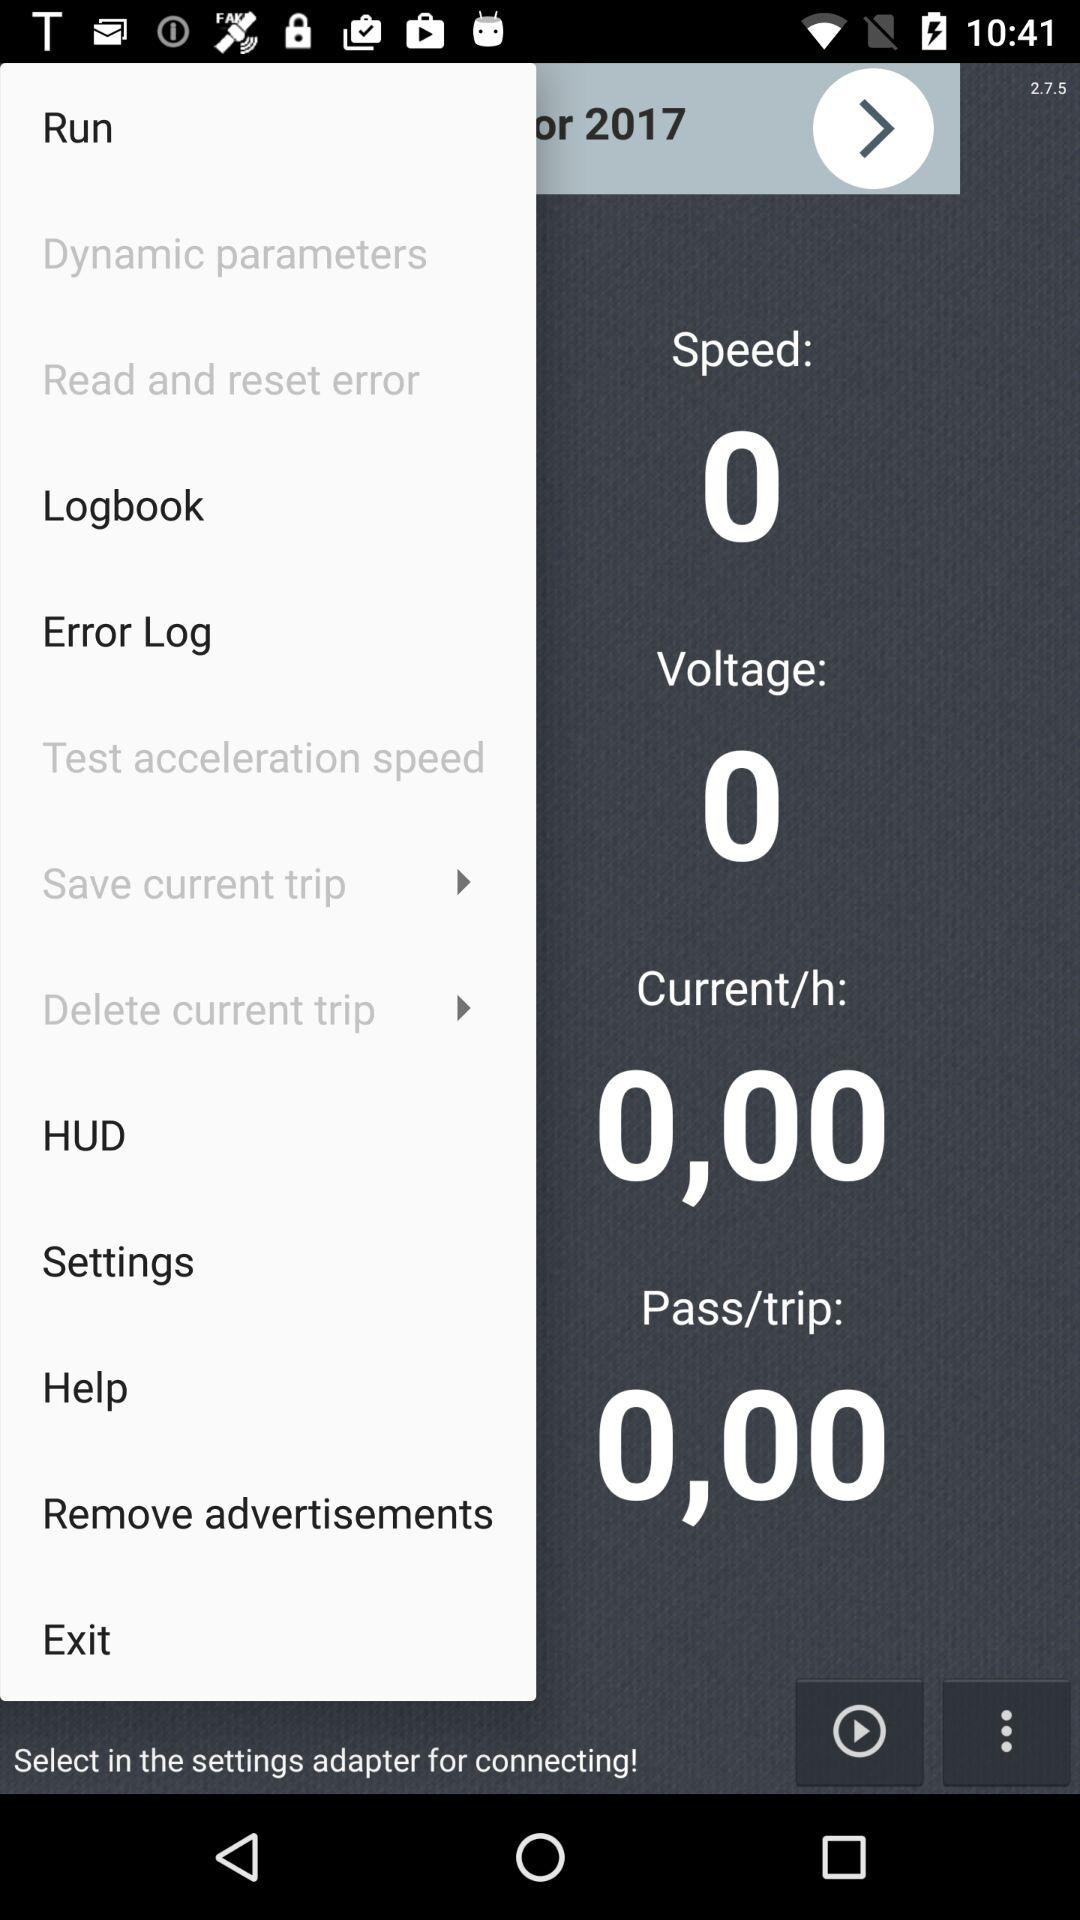What is the "Pass/trip"? The "Pass/trip" is 0. 